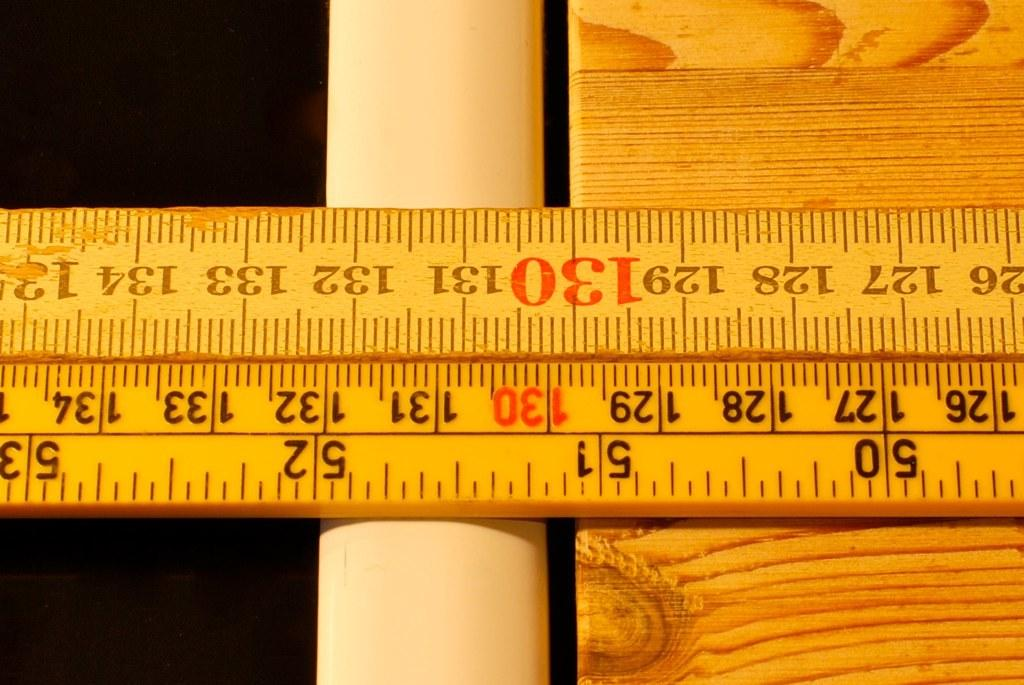<image>
Summarize the visual content of the image. A section of two rulers showing the numbers 126 to 135. 